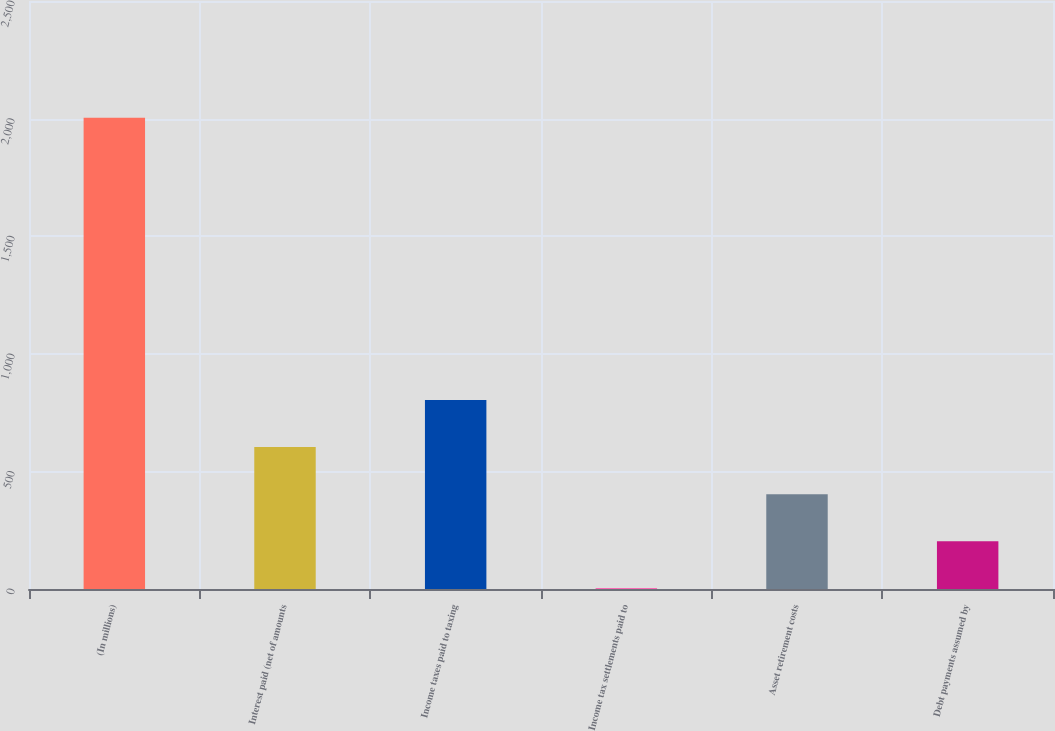Convert chart to OTSL. <chart><loc_0><loc_0><loc_500><loc_500><bar_chart><fcel>(In millions)<fcel>Interest paid (net of amounts<fcel>Income taxes paid to taxing<fcel>Income tax settlements paid to<fcel>Asset retirement costs<fcel>Debt payments assumed by<nl><fcel>2004<fcel>603.3<fcel>803.4<fcel>3<fcel>403.2<fcel>203.1<nl></chart> 